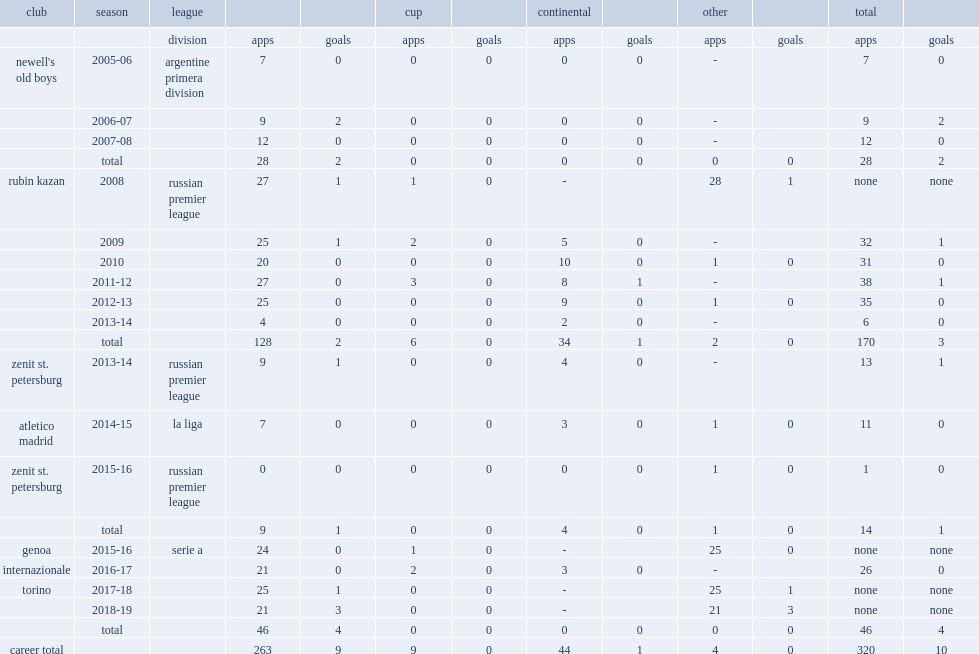In 2017-18, which league did cristian ansaldi join in the torino? Serie a. 